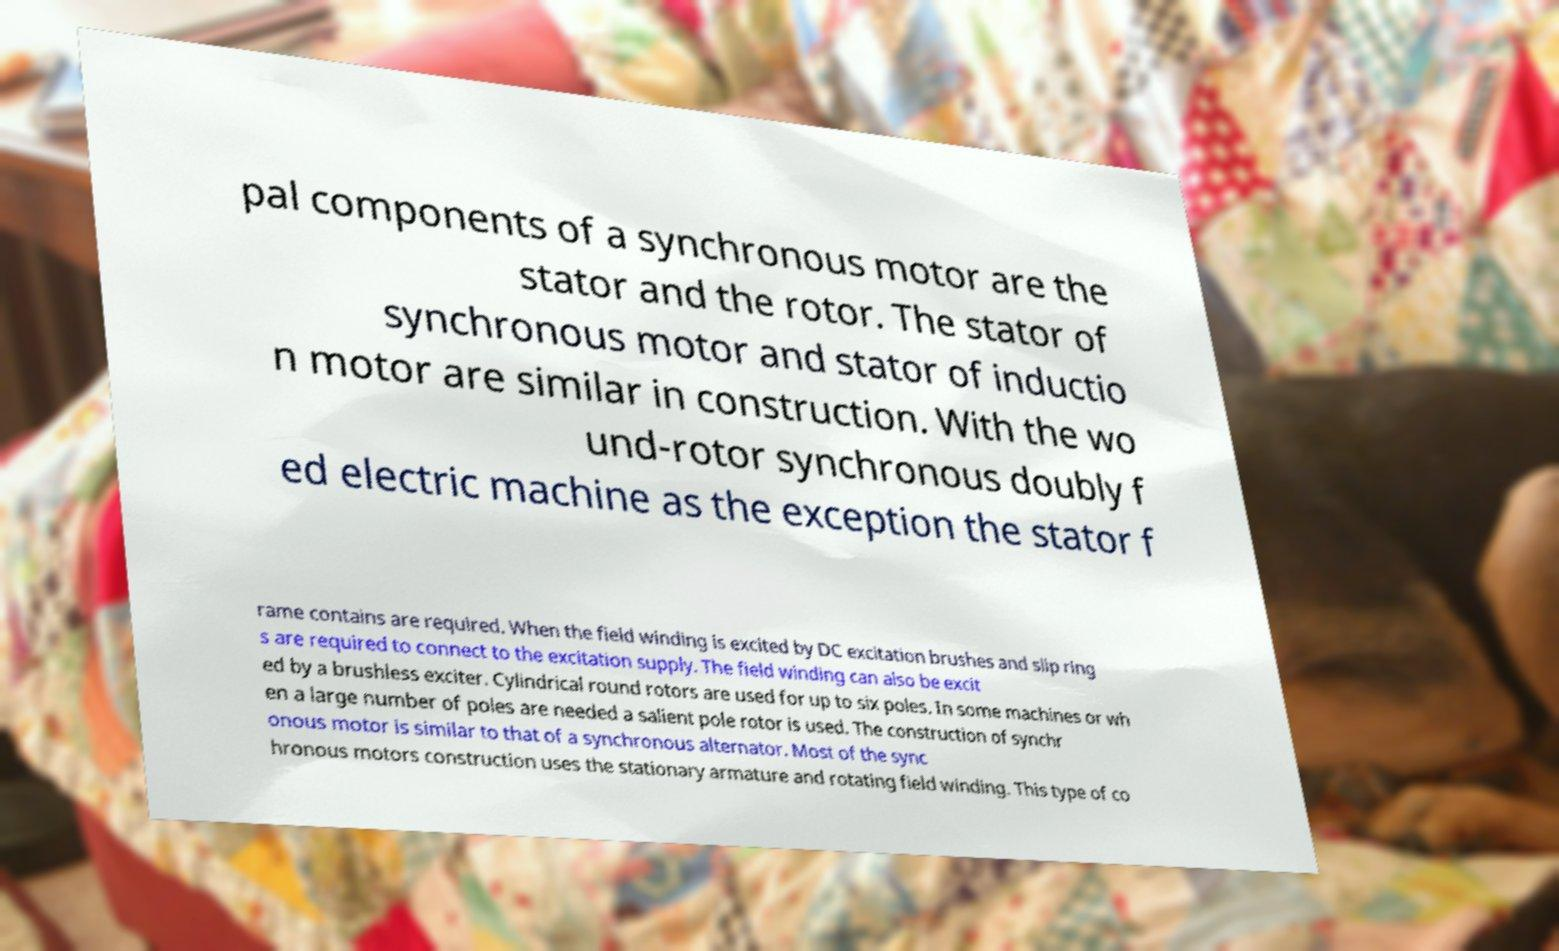Could you assist in decoding the text presented in this image and type it out clearly? pal components of a synchronous motor are the stator and the rotor. The stator of synchronous motor and stator of inductio n motor are similar in construction. With the wo und-rotor synchronous doubly f ed electric machine as the exception the stator f rame contains are required. When the field winding is excited by DC excitation brushes and slip ring s are required to connect to the excitation supply. The field winding can also be excit ed by a brushless exciter. Cylindrical round rotors are used for up to six poles. In some machines or wh en a large number of poles are needed a salient pole rotor is used. The construction of synchr onous motor is similar to that of a synchronous alternator. Most of the sync hronous motors construction uses the stationary armature and rotating field winding. This type of co 